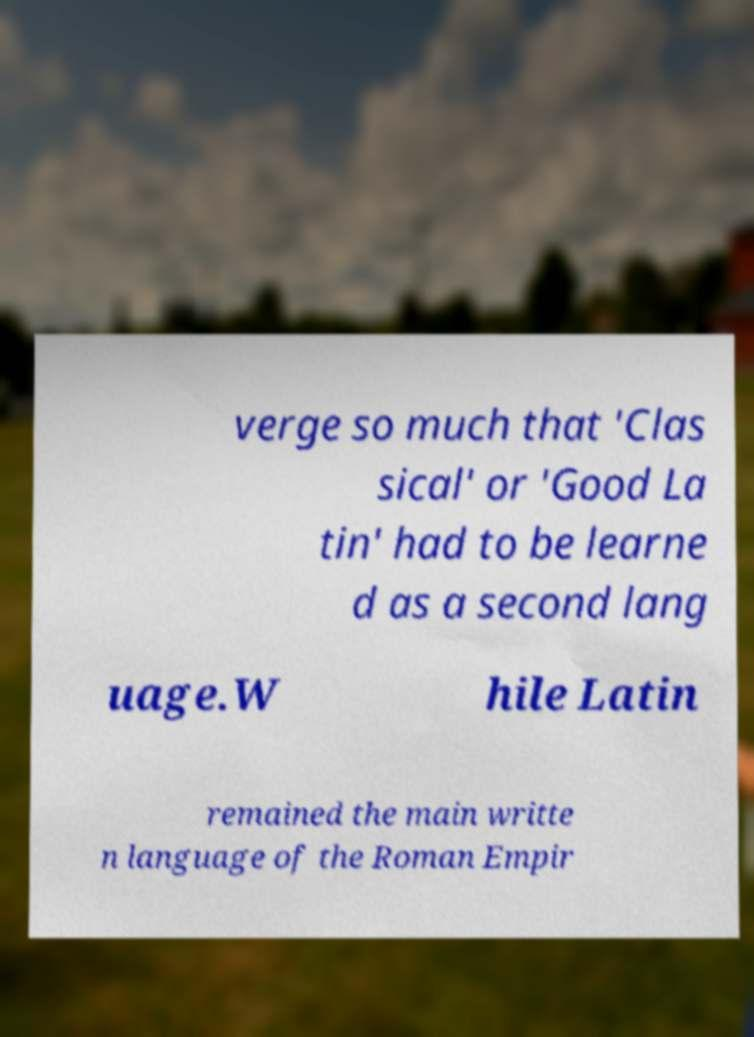I need the written content from this picture converted into text. Can you do that? verge so much that 'Clas sical' or 'Good La tin' had to be learne d as a second lang uage.W hile Latin remained the main writte n language of the Roman Empir 